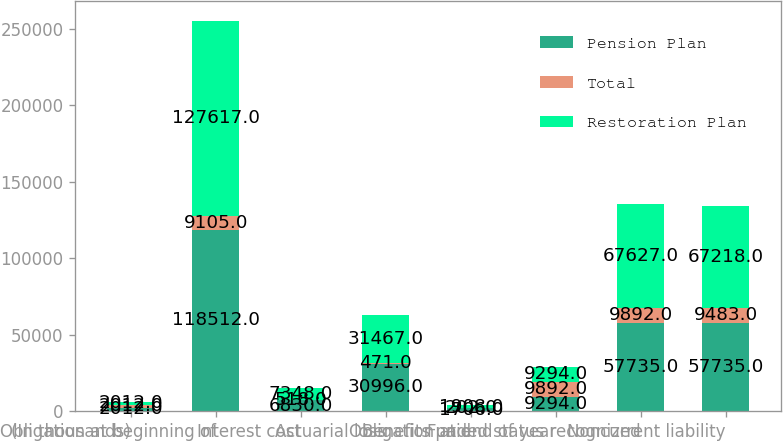Convert chart. <chart><loc_0><loc_0><loc_500><loc_500><stacked_bar_chart><ecel><fcel>(In thousands)<fcel>Obligation at beginning of<fcel>Interest cost<fcel>Actuarial loss<fcel>Benefits paid<fcel>Obligation at end of year<fcel>Funded status recognized<fcel>Noncurrent liability<nl><fcel>Pension Plan<fcel>2012<fcel>118512<fcel>6830<fcel>30996<fcel>1706<fcel>9294<fcel>57735<fcel>57735<nl><fcel>Total<fcel>2012<fcel>9105<fcel>518<fcel>471<fcel>202<fcel>9892<fcel>9892<fcel>9483<nl><fcel>Restoration Plan<fcel>2012<fcel>127617<fcel>7348<fcel>31467<fcel>1908<fcel>9294<fcel>67627<fcel>67218<nl></chart> 